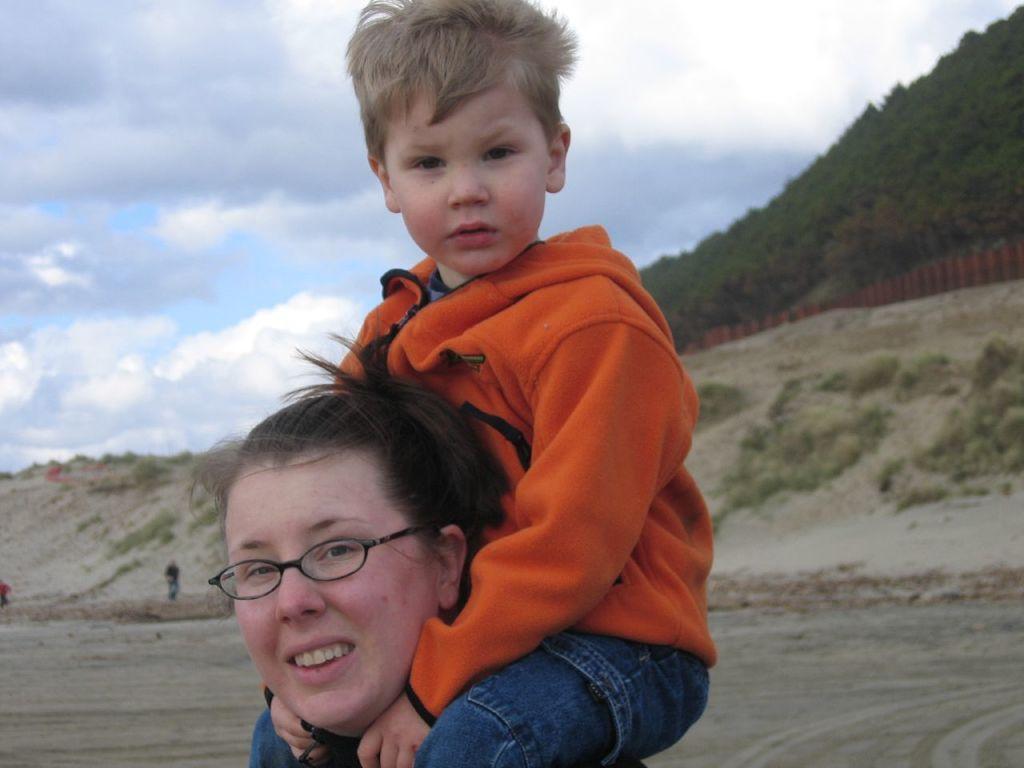How would you summarize this image in a sentence or two? In this image we can see a boy on the shoulder of a woman. In the background, we can see land, plants and people. At the top of the image, we can see the sky with clouds. On the right side of the image, we can see greenery and the fence. 